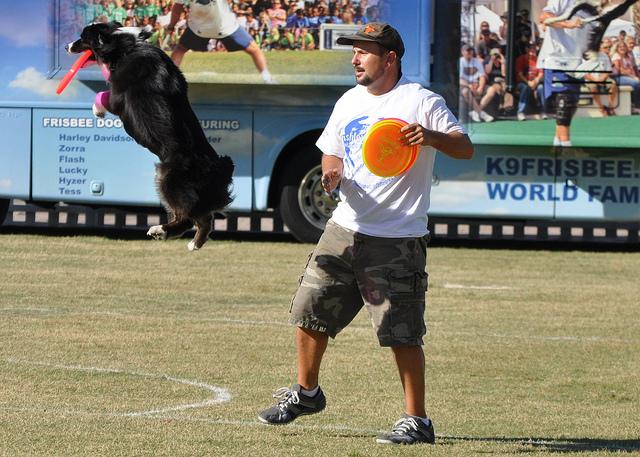What is in the man's hand?
Keep it brief. Frisbee. Are there more than one frisbee?
Short answer required. Yes. Has this dog had training?
Give a very brief answer. Yes. 